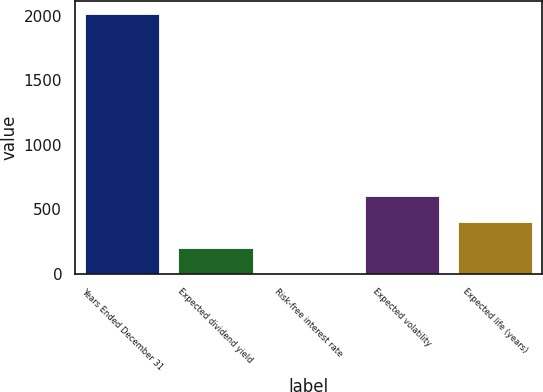Convert chart. <chart><loc_0><loc_0><loc_500><loc_500><bar_chart><fcel>Years Ended December 31<fcel>Expected dividend yield<fcel>Risk-free interest rate<fcel>Expected volatility<fcel>Expected life (years)<nl><fcel>2017<fcel>203.5<fcel>2<fcel>606.5<fcel>405<nl></chart> 